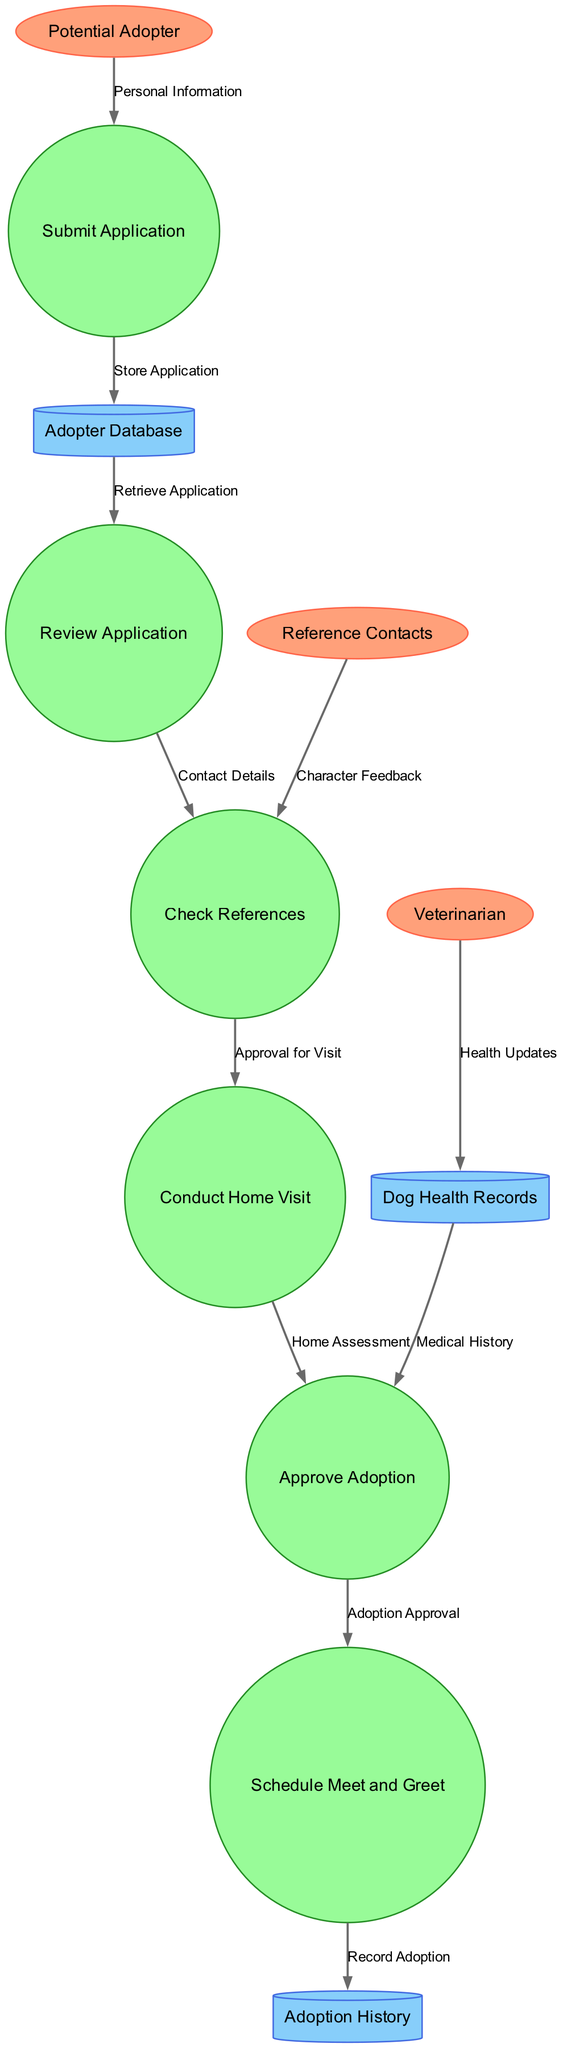What are the external entities in this diagram? The external entities include "Potential Adopter," "Veterinarian," and "Reference Contacts," which are represented as ellipses in the diagram.
Answer: Potential Adopter, Veterinarian, Reference Contacts How many processes are there in the workflow? There are six processes, which are represented as circles in the diagram. They include "Submit Application," "Review Application," "Check References," "Conduct Home Visit," "Approve Adoption," and "Schedule Meet and Greet."
Answer: 6 Which data store retrieves the application for review? The "Adopter Database" retrieves the application and is linked to the "Review Application" process, representing the flow of information.
Answer: Adopter Database What is the data flow from "Check References" to "Conduct Home Visit" labeled as? The label for the data flow from "Check References" to "Conduct Home Visit" is "Approval for Visit," indicating the approval necessary for proceeding with the home visit.
Answer: Approval for Visit What is the final step in the adoption workflow? The final step in the workflow is to "Record Adoption" in the "Adoption History" data store after the "Schedule Meet and Greet" process is completed.
Answer: Record Adoption Which process receives updates from the veterinarian? The "Dog Health Records" store receives health updates from the "Veterinarian," indicating the medical history of the dogs involved in the adoption process.
Answer: Dog Health Records Which external entity provides character feedback? The "Reference Contacts" provide character feedback during the "Check References" process, which is crucial for assessing potential adopters.
Answer: Reference Contacts What type of diagram is displayed in this workflow? This is a Data Flow Diagram, which illustrates the flow of information between processes, data stores, and external entities involved in the adoption application and approval workflow.
Answer: Data Flow Diagram 